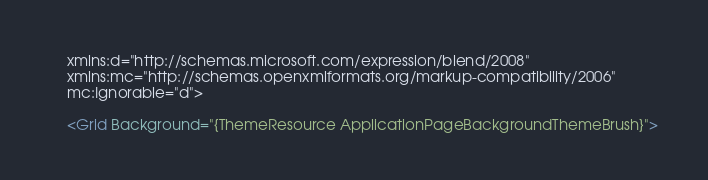Convert code to text. <code><loc_0><loc_0><loc_500><loc_500><_XML_>    xmlns:d="http://schemas.microsoft.com/expression/blend/2008"
    xmlns:mc="http://schemas.openxmlformats.org/markup-compatibility/2006"
    mc:Ignorable="d">

    <Grid Background="{ThemeResource ApplicationPageBackgroundThemeBrush}"></code> 